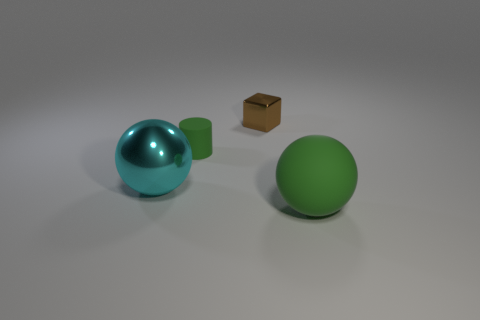Add 3 small matte cylinders. How many objects exist? 7 Subtract all cylinders. How many objects are left? 3 Subtract all large blue rubber objects. Subtract all brown things. How many objects are left? 3 Add 1 metal blocks. How many metal blocks are left? 2 Add 4 big yellow matte balls. How many big yellow matte balls exist? 4 Subtract 0 brown cylinders. How many objects are left? 4 